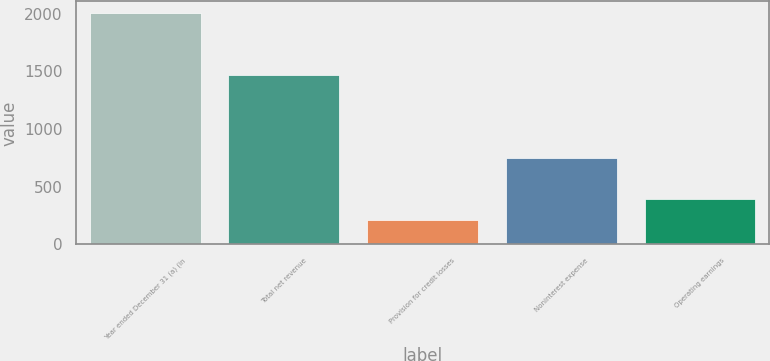Convert chart to OTSL. <chart><loc_0><loc_0><loc_500><loc_500><bar_chart><fcel>Year ended December 31 (a) (in<fcel>Total net revenue<fcel>Provision for credit losses<fcel>Noninterest expense<fcel>Operating earnings<nl><fcel>2005<fcel>1467<fcel>212<fcel>751<fcel>391.3<nl></chart> 